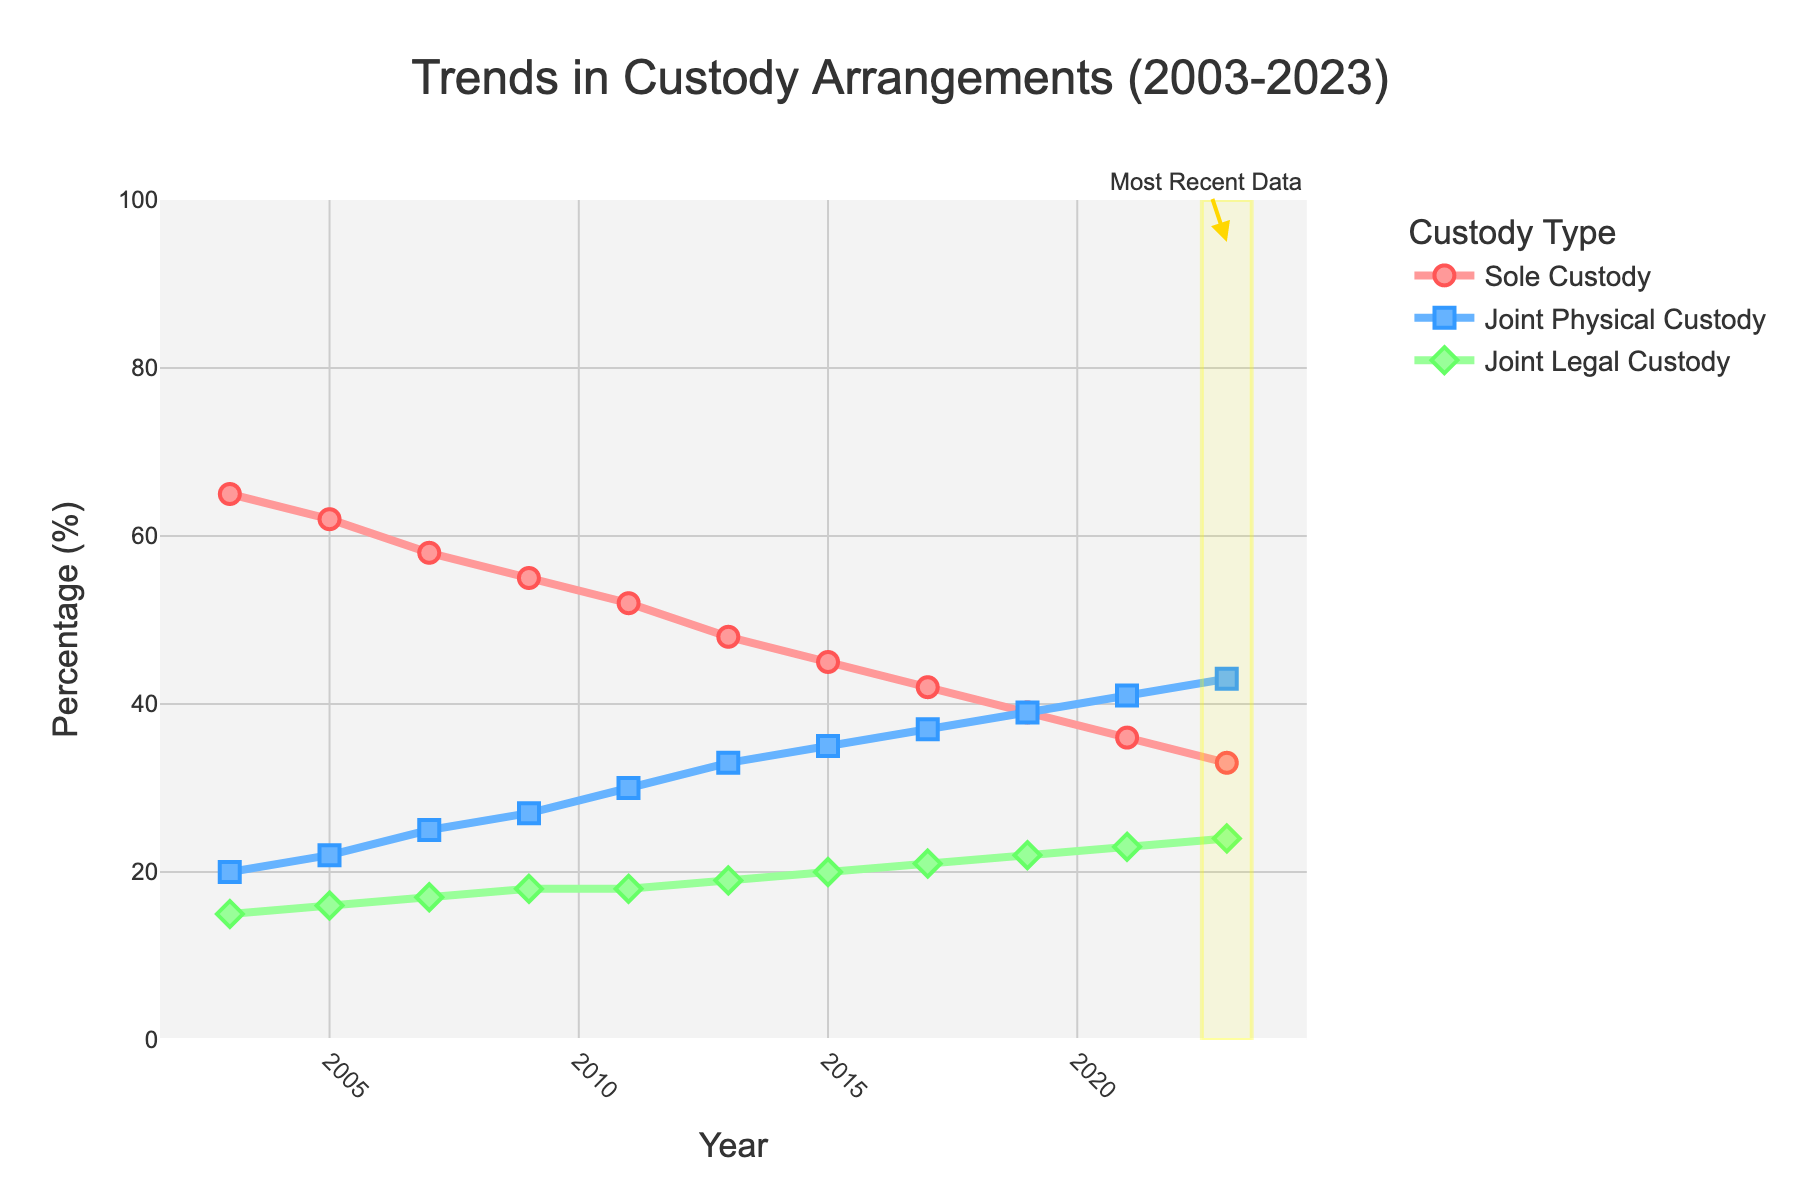What is the trend in "Sole Custody (%)" over time? From the chart, "Sole Custody (%)" consistently decreases from 65% in 2003 to 33% in 2023.
Answer: Decreasing trend What year did "Joint Physical Custody (%)" surpass "Joint Legal Custody (%)"? Checking the intersection of the lines, "Joint Physical Custody (%)" surpassed "Joint Legal Custody (%)" between 2005 and 2007. Therefore, in 2007, "Joint Physical Custody (%)" surpassed "Joint Legal Custody (%)".
Answer: 2007 How much did "Joint Physical Custody (%)" increase from 2003 to 2023? By subtracting the percentage in 2003 from the percentage in 2023, the increase is 43% - 20% = 23%.
Answer: 23% Which custody type has the smallest increase over 20 years? By comparing the starting and ending values for each custody type: "Sole Custody (%)" decreased, "Joint Physical Custody (%)" increased by 23%, and "Joint Legal Custody (%)" increased by 9%. "Joint Legal Custody (%)" has the smallest increase.
Answer: Joint Legal Custody (%) In 2023, which custody type has the highest percentage? From the 2023 data, "Joint Physical Custody (%)" has the highest percentage at 43%.
Answer: Joint Physical Custody (%) Compare the trend of "Sole Custody (%)" and "Joint Physical Custody (%)". "Sole Custody (%)" shows a consistent decreasing trend, whereas "Joint Physical Custody (%)" shows a consistent increasing trend over time.
Answer: Sole Custody decreasing, Joint Physical Custody increasing By how many percentage points did "Joint Legal Custody (%)" change from 2003 to 2023? The percentage in 2023 is 24% and in 2003 is 15%, so the change is 24% - 15% = 9 percentage points.
Answer: 9 percentage points In which year was the percentage of "Sole Custody (%)" half of what it was in 2003? Half of 65% (the percentage in 2003) is 32.5%. By examining the chart, the percentage in 2023 (around 33%) is closest to half of 65%.
Answer: 2023 